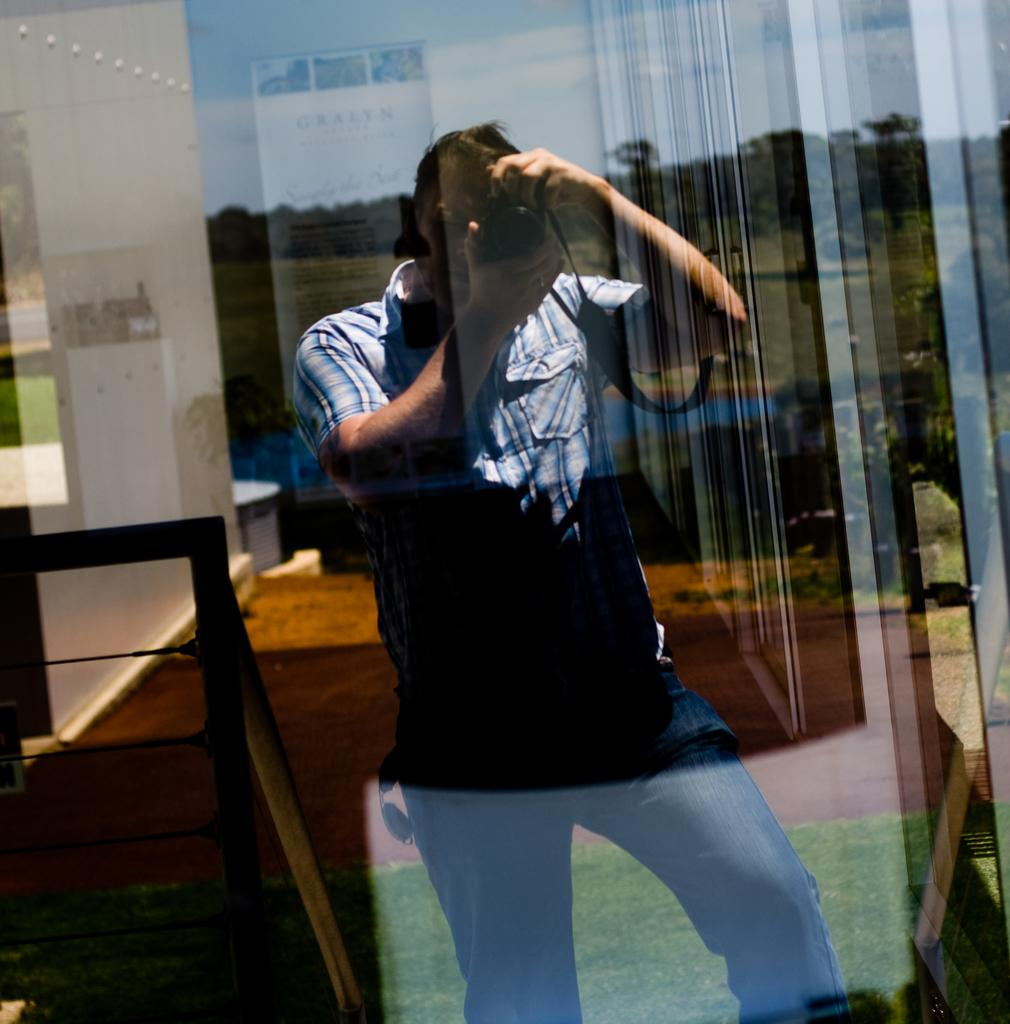What is the main subject of the image? There is a person in the image. What is the person holding in their hands? The person is holding a camera in their hands. What can be seen in the background of the image? There are trees, the sky, and other objects visible in the background of the image. What type of toothbrush is the person using to take the picture in the image? There is no toothbrush present in the image, and the person is not using one to take the picture. 